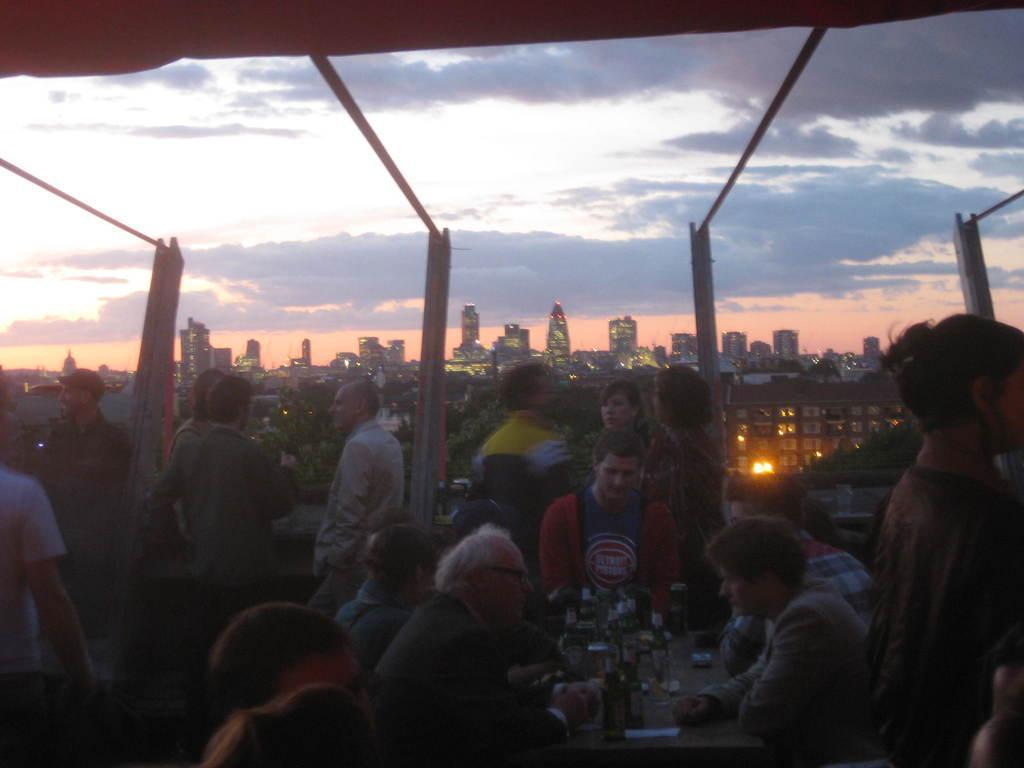Please provide a concise description of this image. In this image we can see some people and there is a table in front of the people and on the table we can see bottles and some other objects. In the background, we can see some buildings and trees and there is a sky with the clouds at the top. 